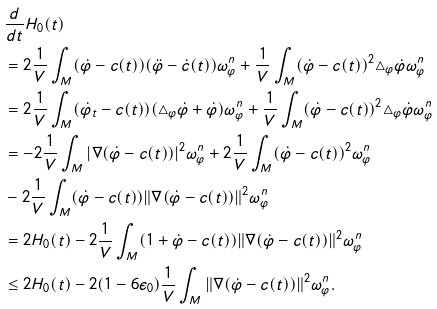Convert formula to latex. <formula><loc_0><loc_0><loc_500><loc_500>& \frac { d } { d t } H _ { 0 } ( t ) \\ & = 2 \frac { 1 } { V } \int _ { M } ( \dot { \varphi } - c ( t ) ) ( \ddot { \varphi } - \dot { c } ( t ) ) \omega ^ { n } _ { \varphi } + \frac { 1 } { V } \int _ { M } ( \dot { \varphi } - c ( t ) ) ^ { 2 } \triangle _ { \varphi } \dot { \varphi } \omega _ { \varphi } ^ { n } \\ & = 2 \frac { 1 } { V } \int _ { M } ( \dot { \varphi } _ { t } - c ( t ) ) ( \triangle _ { \varphi } \dot { \varphi } + \dot { \varphi } ) \omega ^ { n } _ { \varphi } + \frac { 1 } { V } \int _ { M } ( \dot { \varphi } - c ( t ) ) ^ { 2 } \triangle _ { \varphi } \dot { \varphi } \omega _ { \varphi } ^ { n } \\ & = - 2 \frac { 1 } { V } \int _ { M } | \nabla ( \dot { \varphi } - c ( t ) ) | ^ { 2 } \omega ^ { n } _ { \varphi } + 2 \frac { 1 } { V } \int _ { M } ( \dot { \varphi } - c ( t ) ) ^ { 2 } \omega ^ { n } _ { \varphi } \\ & - 2 \frac { 1 } { V } \int _ { M } ( \dot { \varphi } - c ( t ) ) \| \nabla ( \dot { \varphi } - c ( t ) ) \| ^ { 2 } \omega _ { \varphi } ^ { n } \\ & = 2 H _ { 0 } ( t ) - 2 \frac { 1 } { V } \int _ { M } ( 1 + \dot { \varphi } - c ( t ) ) \| \nabla ( \dot { \varphi } - c ( t ) ) \| ^ { 2 } \omega _ { \varphi } ^ { n } \\ & \leq 2 H _ { 0 } ( t ) - 2 ( 1 - 6 \epsilon _ { 0 } ) \frac { 1 } { V } \int _ { M } \| \nabla ( \dot { \varphi } - c ( t ) ) \| ^ { 2 } \omega _ { \varphi } ^ { n } .</formula> 